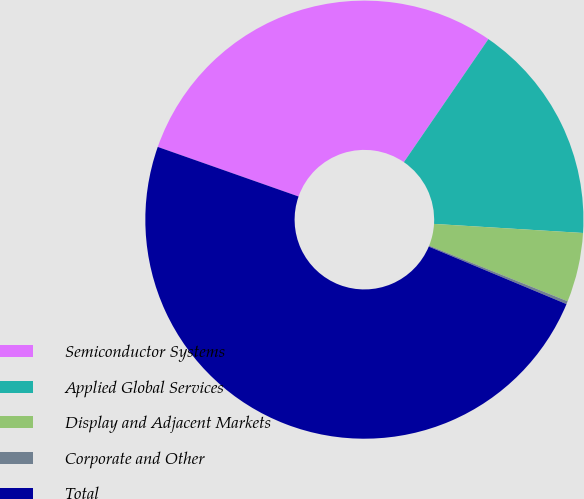Convert chart. <chart><loc_0><loc_0><loc_500><loc_500><pie_chart><fcel>Semiconductor Systems<fcel>Applied Global Services<fcel>Display and Adjacent Markets<fcel>Corporate and Other<fcel>Total<nl><fcel>29.19%<fcel>16.39%<fcel>5.11%<fcel>0.22%<fcel>49.09%<nl></chart> 